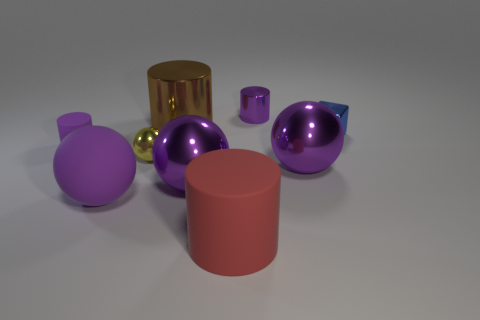Can you describe the objects that are closest to the gold cylinder? Certainly! Close to the gold cylinder, there are two spherical objects: one is small and yellow, and the other is larger and purple. They both exhibit a reflective surface, indicating a metallic finish. Do the purple objects have the same finish? The purple objects indeed share a similar glossy, metallic finish, suggesting that they are made of the same or a similar material. 